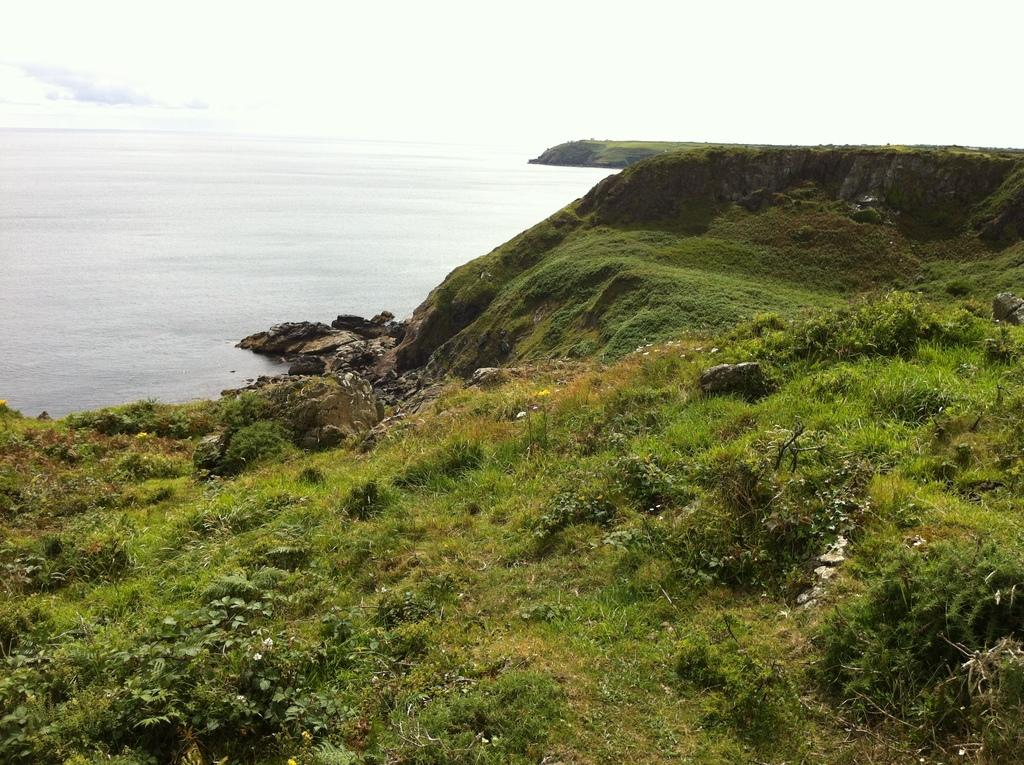What type of terrain is depicted in the image? The image shows hills. What can be found on the hills? The hills have plants, grass, and rocks. Is there any water visible in the image? Yes, there is water visible in the image. What can be seen in the background of the image? The sky is visible in the background of the image. What type of fuel is being used by the plants on the hills in the image? There is no indication in the image that the plants are using any type of fuel. Plants typically produce their own energy through photosynthesis. 